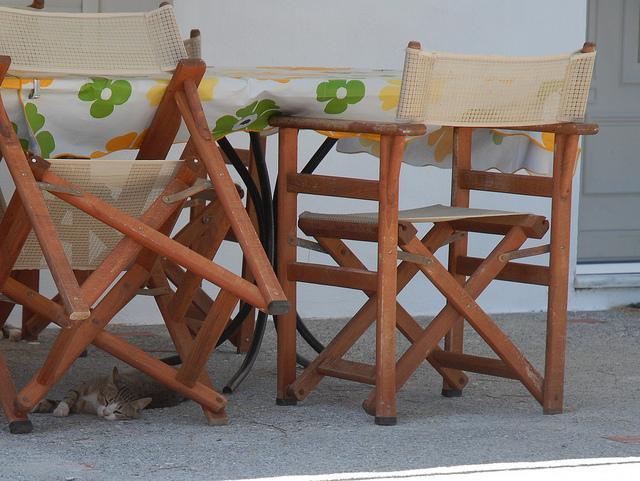How many chairs are there?
Give a very brief answer. 2. How many big bear are there in the image?
Give a very brief answer. 0. 